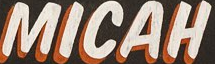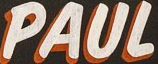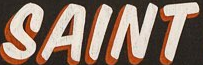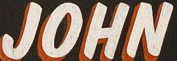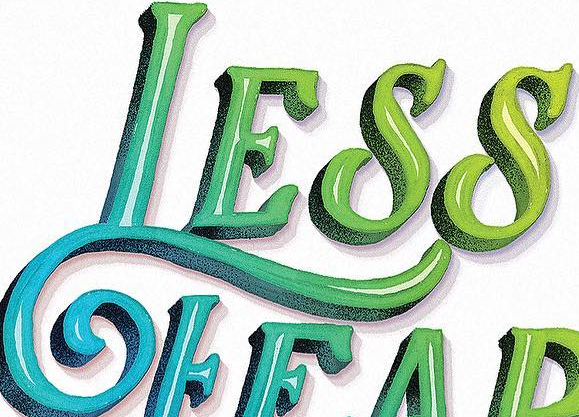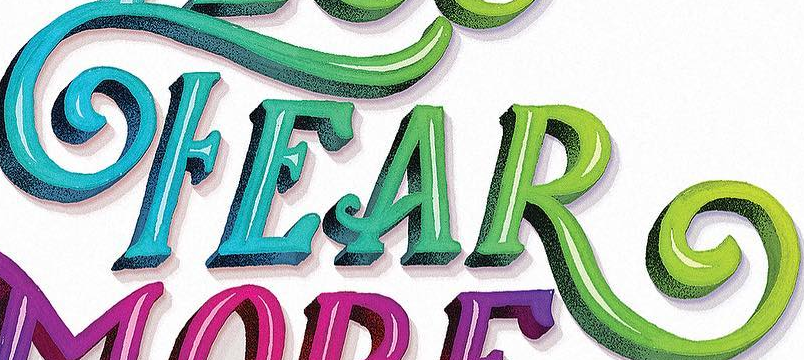What words can you see in these images in sequence, separated by a semicolon? MICAH; PAUL; SAINT; JOHN; LESS; FEAR 